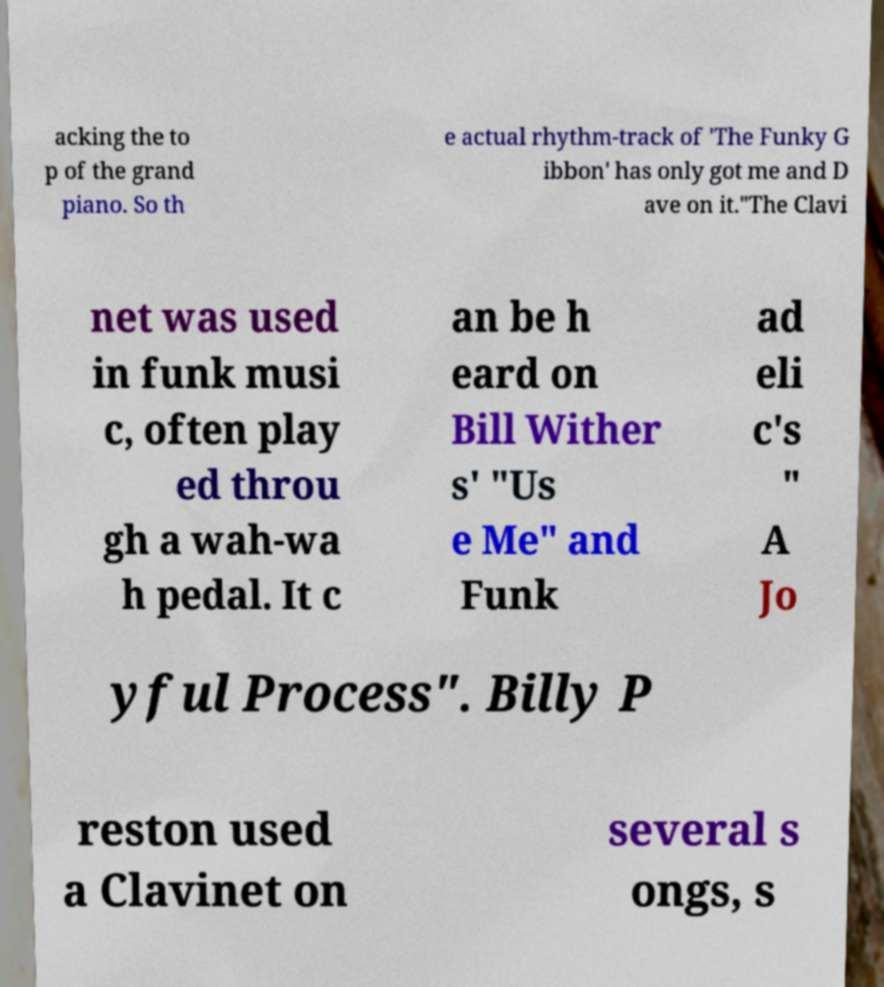There's text embedded in this image that I need extracted. Can you transcribe it verbatim? acking the to p of the grand piano. So th e actual rhythm-track of 'The Funky G ibbon' has only got me and D ave on it."The Clavi net was used in funk musi c, often play ed throu gh a wah-wa h pedal. It c an be h eard on Bill Wither s' "Us e Me" and Funk ad eli c's " A Jo yful Process". Billy P reston used a Clavinet on several s ongs, s 